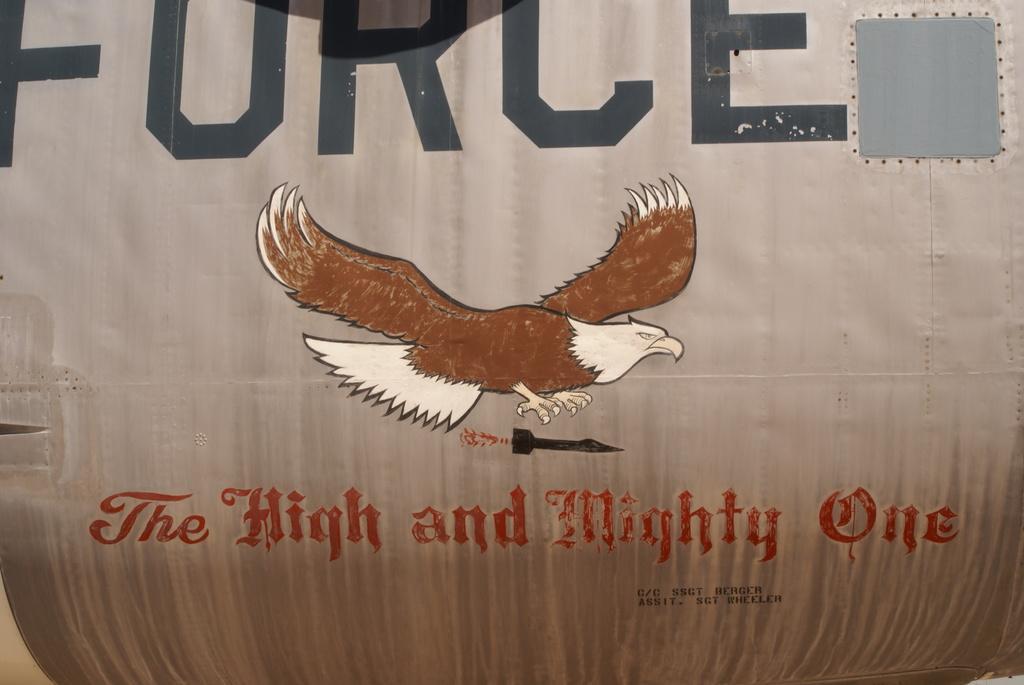Please provide a concise description of this image. In the image there is a eagle painting on the wall with some text above and below it. 